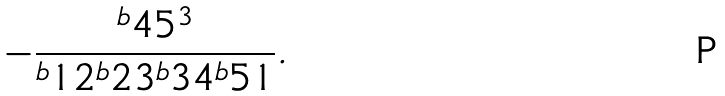Convert formula to latex. <formula><loc_0><loc_0><loc_500><loc_500>- \frac { ^ { b } 4 5 ^ { 3 } } { ^ { b } 1 2 ^ { b } 2 3 ^ { b } 3 4 ^ { b } 5 1 } .</formula> 